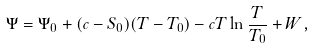<formula> <loc_0><loc_0><loc_500><loc_500>\Psi = \Psi _ { 0 } + ( c - S _ { 0 } ) ( T - T _ { 0 } ) - c T \ln \frac { T } { T _ { 0 } } + W ,</formula> 